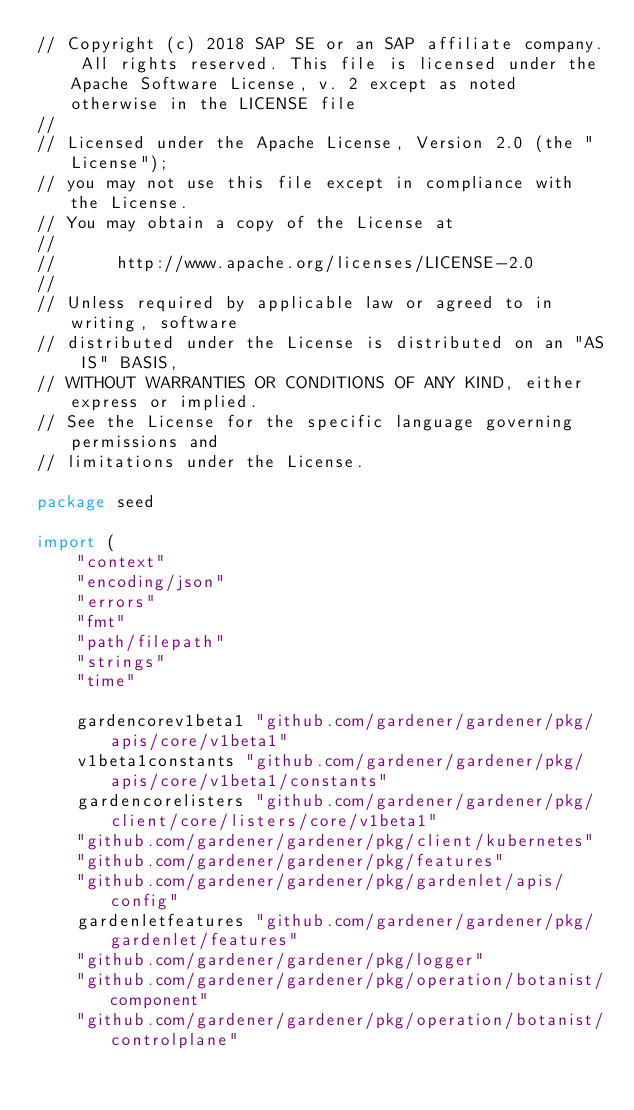<code> <loc_0><loc_0><loc_500><loc_500><_Go_>// Copyright (c) 2018 SAP SE or an SAP affiliate company. All rights reserved. This file is licensed under the Apache Software License, v. 2 except as noted otherwise in the LICENSE file
//
// Licensed under the Apache License, Version 2.0 (the "License");
// you may not use this file except in compliance with the License.
// You may obtain a copy of the License at
//
//      http://www.apache.org/licenses/LICENSE-2.0
//
// Unless required by applicable law or agreed to in writing, software
// distributed under the License is distributed on an "AS IS" BASIS,
// WITHOUT WARRANTIES OR CONDITIONS OF ANY KIND, either express or implied.
// See the License for the specific language governing permissions and
// limitations under the License.

package seed

import (
	"context"
	"encoding/json"
	"errors"
	"fmt"
	"path/filepath"
	"strings"
	"time"

	gardencorev1beta1 "github.com/gardener/gardener/pkg/apis/core/v1beta1"
	v1beta1constants "github.com/gardener/gardener/pkg/apis/core/v1beta1/constants"
	gardencorelisters "github.com/gardener/gardener/pkg/client/core/listers/core/v1beta1"
	"github.com/gardener/gardener/pkg/client/kubernetes"
	"github.com/gardener/gardener/pkg/features"
	"github.com/gardener/gardener/pkg/gardenlet/apis/config"
	gardenletfeatures "github.com/gardener/gardener/pkg/gardenlet/features"
	"github.com/gardener/gardener/pkg/logger"
	"github.com/gardener/gardener/pkg/operation/botanist/component"
	"github.com/gardener/gardener/pkg/operation/botanist/controlplane"</code> 